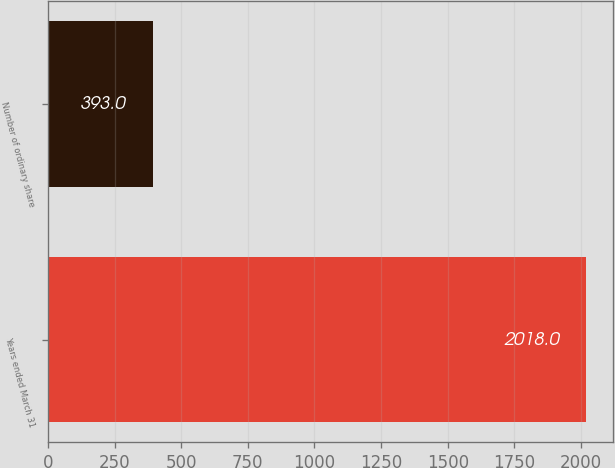<chart> <loc_0><loc_0><loc_500><loc_500><bar_chart><fcel>Years ended March 31<fcel>Number of ordinary share<nl><fcel>2018<fcel>393<nl></chart> 